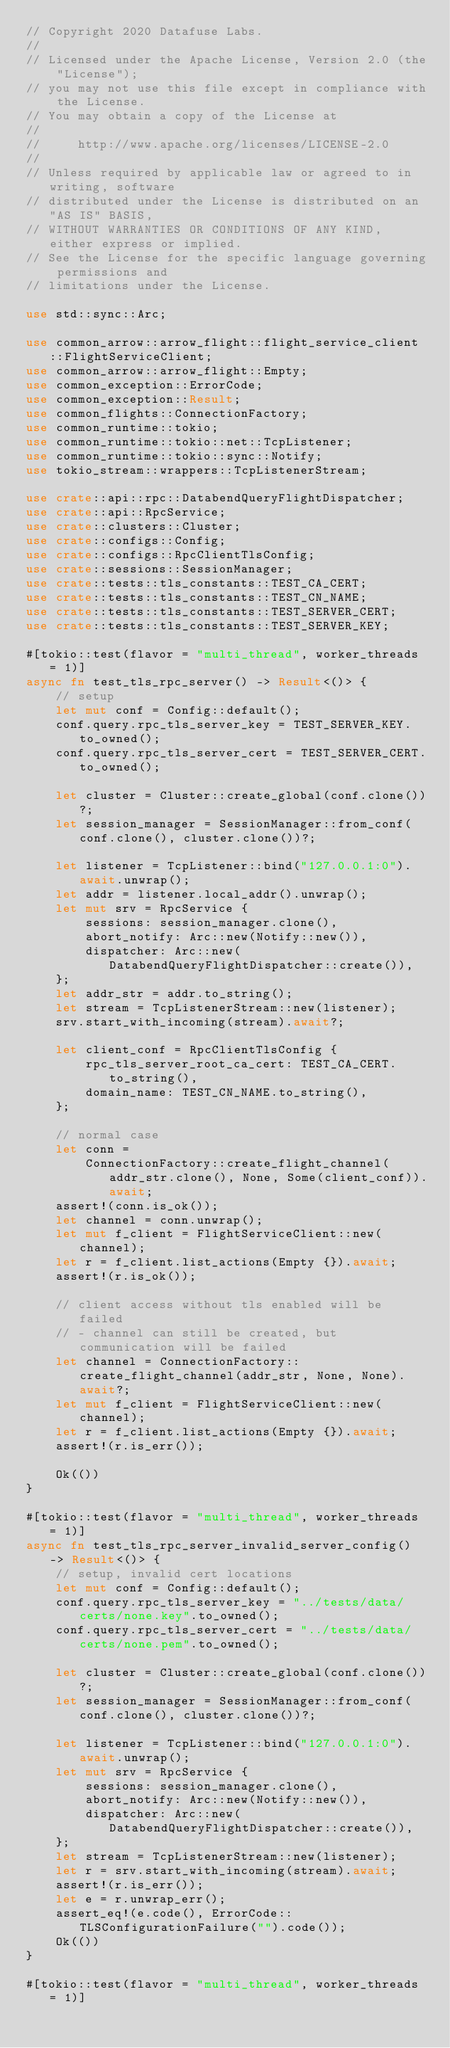Convert code to text. <code><loc_0><loc_0><loc_500><loc_500><_Rust_>// Copyright 2020 Datafuse Labs.
//
// Licensed under the Apache License, Version 2.0 (the "License");
// you may not use this file except in compliance with the License.
// You may obtain a copy of the License at
//
//     http://www.apache.org/licenses/LICENSE-2.0
//
// Unless required by applicable law or agreed to in writing, software
// distributed under the License is distributed on an "AS IS" BASIS,
// WITHOUT WARRANTIES OR CONDITIONS OF ANY KIND, either express or implied.
// See the License for the specific language governing permissions and
// limitations under the License.

use std::sync::Arc;

use common_arrow::arrow_flight::flight_service_client::FlightServiceClient;
use common_arrow::arrow_flight::Empty;
use common_exception::ErrorCode;
use common_exception::Result;
use common_flights::ConnectionFactory;
use common_runtime::tokio;
use common_runtime::tokio::net::TcpListener;
use common_runtime::tokio::sync::Notify;
use tokio_stream::wrappers::TcpListenerStream;

use crate::api::rpc::DatabendQueryFlightDispatcher;
use crate::api::RpcService;
use crate::clusters::Cluster;
use crate::configs::Config;
use crate::configs::RpcClientTlsConfig;
use crate::sessions::SessionManager;
use crate::tests::tls_constants::TEST_CA_CERT;
use crate::tests::tls_constants::TEST_CN_NAME;
use crate::tests::tls_constants::TEST_SERVER_CERT;
use crate::tests::tls_constants::TEST_SERVER_KEY;

#[tokio::test(flavor = "multi_thread", worker_threads = 1)]
async fn test_tls_rpc_server() -> Result<()> {
    // setup
    let mut conf = Config::default();
    conf.query.rpc_tls_server_key = TEST_SERVER_KEY.to_owned();
    conf.query.rpc_tls_server_cert = TEST_SERVER_CERT.to_owned();

    let cluster = Cluster::create_global(conf.clone())?;
    let session_manager = SessionManager::from_conf(conf.clone(), cluster.clone())?;

    let listener = TcpListener::bind("127.0.0.1:0").await.unwrap();
    let addr = listener.local_addr().unwrap();
    let mut srv = RpcService {
        sessions: session_manager.clone(),
        abort_notify: Arc::new(Notify::new()),
        dispatcher: Arc::new(DatabendQueryFlightDispatcher::create()),
    };
    let addr_str = addr.to_string();
    let stream = TcpListenerStream::new(listener);
    srv.start_with_incoming(stream).await?;

    let client_conf = RpcClientTlsConfig {
        rpc_tls_server_root_ca_cert: TEST_CA_CERT.to_string(),
        domain_name: TEST_CN_NAME.to_string(),
    };

    // normal case
    let conn =
        ConnectionFactory::create_flight_channel(addr_str.clone(), None, Some(client_conf)).await;
    assert!(conn.is_ok());
    let channel = conn.unwrap();
    let mut f_client = FlightServiceClient::new(channel);
    let r = f_client.list_actions(Empty {}).await;
    assert!(r.is_ok());

    // client access without tls enabled will be failed
    // - channel can still be created, but communication will be failed
    let channel = ConnectionFactory::create_flight_channel(addr_str, None, None).await?;
    let mut f_client = FlightServiceClient::new(channel);
    let r = f_client.list_actions(Empty {}).await;
    assert!(r.is_err());

    Ok(())
}

#[tokio::test(flavor = "multi_thread", worker_threads = 1)]
async fn test_tls_rpc_server_invalid_server_config() -> Result<()> {
    // setup, invalid cert locations
    let mut conf = Config::default();
    conf.query.rpc_tls_server_key = "../tests/data/certs/none.key".to_owned();
    conf.query.rpc_tls_server_cert = "../tests/data/certs/none.pem".to_owned();

    let cluster = Cluster::create_global(conf.clone())?;
    let session_manager = SessionManager::from_conf(conf.clone(), cluster.clone())?;

    let listener = TcpListener::bind("127.0.0.1:0").await.unwrap();
    let mut srv = RpcService {
        sessions: session_manager.clone(),
        abort_notify: Arc::new(Notify::new()),
        dispatcher: Arc::new(DatabendQueryFlightDispatcher::create()),
    };
    let stream = TcpListenerStream::new(listener);
    let r = srv.start_with_incoming(stream).await;
    assert!(r.is_err());
    let e = r.unwrap_err();
    assert_eq!(e.code(), ErrorCode::TLSConfigurationFailure("").code());
    Ok(())
}

#[tokio::test(flavor = "multi_thread", worker_threads = 1)]</code> 